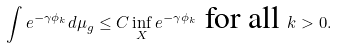Convert formula to latex. <formula><loc_0><loc_0><loc_500><loc_500>\int e ^ { - \gamma \phi _ { k } } d \mu _ { g } \leq C \, \underset { X } { \inf } \, e ^ { - \gamma \phi _ { k } } \text { for all } k > 0 .</formula> 